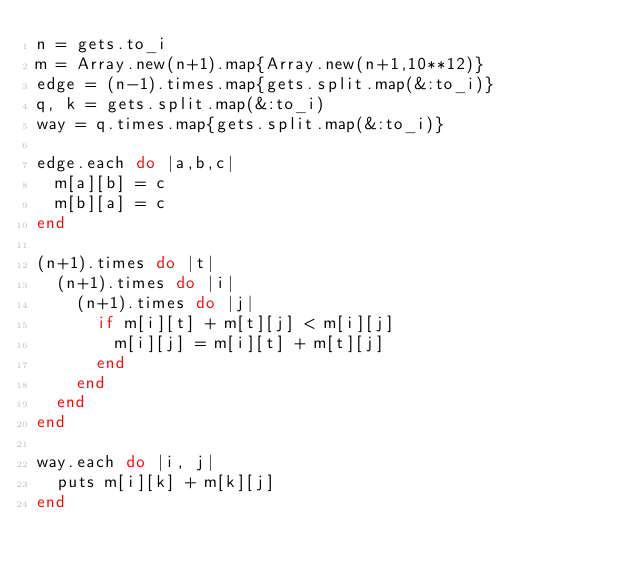Convert code to text. <code><loc_0><loc_0><loc_500><loc_500><_Ruby_>n = gets.to_i
m = Array.new(n+1).map{Array.new(n+1,10**12)}
edge = (n-1).times.map{gets.split.map(&:to_i)}
q, k = gets.split.map(&:to_i)
way = q.times.map{gets.split.map(&:to_i)}

edge.each do |a,b,c|
	m[a][b] = c
	m[b][a] = c
end

(n+1).times do |t|
	(n+1).times do |i|
		(n+1).times do |j|
			if m[i][t] + m[t][j] < m[i][j]
				m[i][j] = m[i][t] + m[t][j]
			end
		end
	end
end

way.each do |i, j|
	puts m[i][k] + m[k][j]
end
</code> 